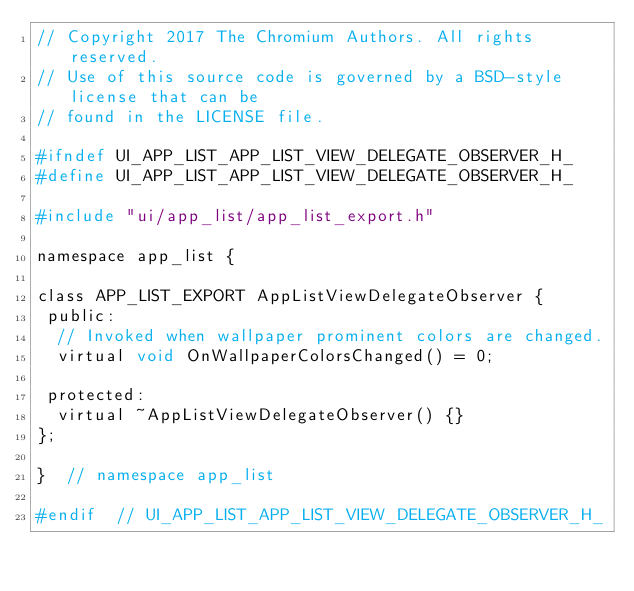<code> <loc_0><loc_0><loc_500><loc_500><_C_>// Copyright 2017 The Chromium Authors. All rights reserved.
// Use of this source code is governed by a BSD-style license that can be
// found in the LICENSE file.

#ifndef UI_APP_LIST_APP_LIST_VIEW_DELEGATE_OBSERVER_H_
#define UI_APP_LIST_APP_LIST_VIEW_DELEGATE_OBSERVER_H_

#include "ui/app_list/app_list_export.h"

namespace app_list {

class APP_LIST_EXPORT AppListViewDelegateObserver {
 public:
  // Invoked when wallpaper prominent colors are changed.
  virtual void OnWallpaperColorsChanged() = 0;

 protected:
  virtual ~AppListViewDelegateObserver() {}
};

}  // namespace app_list

#endif  // UI_APP_LIST_APP_LIST_VIEW_DELEGATE_OBSERVER_H_
</code> 